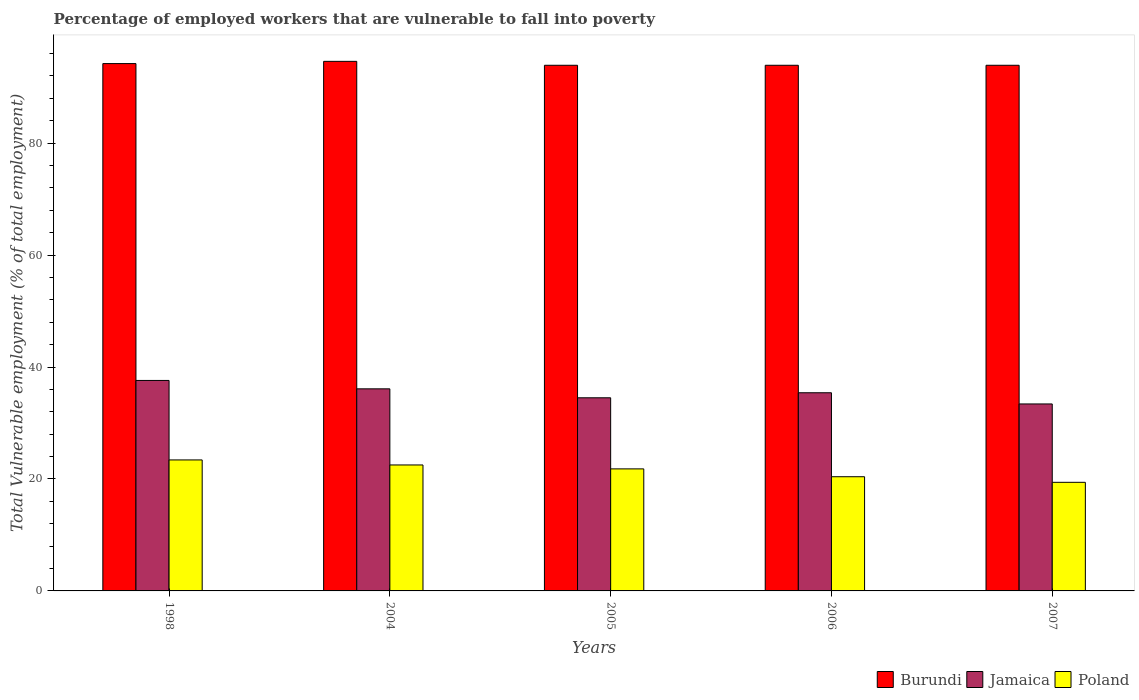How many groups of bars are there?
Provide a short and direct response. 5. Are the number of bars per tick equal to the number of legend labels?
Make the answer very short. Yes. Are the number of bars on each tick of the X-axis equal?
Your response must be concise. Yes. How many bars are there on the 2nd tick from the right?
Provide a short and direct response. 3. What is the percentage of employed workers who are vulnerable to fall into poverty in Poland in 2005?
Keep it short and to the point. 21.8. Across all years, what is the maximum percentage of employed workers who are vulnerable to fall into poverty in Poland?
Provide a succinct answer. 23.4. Across all years, what is the minimum percentage of employed workers who are vulnerable to fall into poverty in Jamaica?
Make the answer very short. 33.4. In which year was the percentage of employed workers who are vulnerable to fall into poverty in Jamaica minimum?
Offer a terse response. 2007. What is the total percentage of employed workers who are vulnerable to fall into poverty in Jamaica in the graph?
Provide a short and direct response. 177. What is the difference between the percentage of employed workers who are vulnerable to fall into poverty in Jamaica in 2004 and that in 2006?
Your response must be concise. 0.7. What is the difference between the percentage of employed workers who are vulnerable to fall into poverty in Burundi in 2007 and the percentage of employed workers who are vulnerable to fall into poverty in Poland in 2005?
Ensure brevity in your answer.  72.1. What is the average percentage of employed workers who are vulnerable to fall into poverty in Jamaica per year?
Offer a very short reply. 35.4. In the year 2005, what is the difference between the percentage of employed workers who are vulnerable to fall into poverty in Burundi and percentage of employed workers who are vulnerable to fall into poverty in Poland?
Provide a succinct answer. 72.1. In how many years, is the percentage of employed workers who are vulnerable to fall into poverty in Jamaica greater than 80 %?
Keep it short and to the point. 0. What is the ratio of the percentage of employed workers who are vulnerable to fall into poverty in Poland in 1998 to that in 2006?
Give a very brief answer. 1.15. Is the percentage of employed workers who are vulnerable to fall into poverty in Poland in 1998 less than that in 2007?
Offer a terse response. No. What is the difference between the highest and the second highest percentage of employed workers who are vulnerable to fall into poverty in Burundi?
Give a very brief answer. 0.4. What is the difference between the highest and the lowest percentage of employed workers who are vulnerable to fall into poverty in Poland?
Your answer should be very brief. 4. What does the 2nd bar from the left in 1998 represents?
Your answer should be very brief. Jamaica. What does the 1st bar from the right in 1998 represents?
Provide a succinct answer. Poland. Is it the case that in every year, the sum of the percentage of employed workers who are vulnerable to fall into poverty in Burundi and percentage of employed workers who are vulnerable to fall into poverty in Jamaica is greater than the percentage of employed workers who are vulnerable to fall into poverty in Poland?
Provide a short and direct response. Yes. How many bars are there?
Your answer should be compact. 15. What is the difference between two consecutive major ticks on the Y-axis?
Offer a terse response. 20. Does the graph contain any zero values?
Your answer should be compact. No. Does the graph contain grids?
Your response must be concise. No. What is the title of the graph?
Your response must be concise. Percentage of employed workers that are vulnerable to fall into poverty. What is the label or title of the X-axis?
Offer a terse response. Years. What is the label or title of the Y-axis?
Ensure brevity in your answer.  Total Vulnerable employment (% of total employment). What is the Total Vulnerable employment (% of total employment) in Burundi in 1998?
Provide a short and direct response. 94.2. What is the Total Vulnerable employment (% of total employment) in Jamaica in 1998?
Provide a succinct answer. 37.6. What is the Total Vulnerable employment (% of total employment) of Poland in 1998?
Keep it short and to the point. 23.4. What is the Total Vulnerable employment (% of total employment) in Burundi in 2004?
Provide a succinct answer. 94.6. What is the Total Vulnerable employment (% of total employment) in Jamaica in 2004?
Your response must be concise. 36.1. What is the Total Vulnerable employment (% of total employment) of Burundi in 2005?
Provide a short and direct response. 93.9. What is the Total Vulnerable employment (% of total employment) of Jamaica in 2005?
Offer a terse response. 34.5. What is the Total Vulnerable employment (% of total employment) in Poland in 2005?
Your answer should be very brief. 21.8. What is the Total Vulnerable employment (% of total employment) of Burundi in 2006?
Your answer should be compact. 93.9. What is the Total Vulnerable employment (% of total employment) in Jamaica in 2006?
Your answer should be compact. 35.4. What is the Total Vulnerable employment (% of total employment) in Poland in 2006?
Offer a very short reply. 20.4. What is the Total Vulnerable employment (% of total employment) in Burundi in 2007?
Provide a short and direct response. 93.9. What is the Total Vulnerable employment (% of total employment) in Jamaica in 2007?
Your response must be concise. 33.4. What is the Total Vulnerable employment (% of total employment) in Poland in 2007?
Provide a short and direct response. 19.4. Across all years, what is the maximum Total Vulnerable employment (% of total employment) of Burundi?
Your answer should be compact. 94.6. Across all years, what is the maximum Total Vulnerable employment (% of total employment) in Jamaica?
Make the answer very short. 37.6. Across all years, what is the maximum Total Vulnerable employment (% of total employment) of Poland?
Give a very brief answer. 23.4. Across all years, what is the minimum Total Vulnerable employment (% of total employment) of Burundi?
Provide a succinct answer. 93.9. Across all years, what is the minimum Total Vulnerable employment (% of total employment) of Jamaica?
Your answer should be compact. 33.4. Across all years, what is the minimum Total Vulnerable employment (% of total employment) of Poland?
Provide a short and direct response. 19.4. What is the total Total Vulnerable employment (% of total employment) of Burundi in the graph?
Keep it short and to the point. 470.5. What is the total Total Vulnerable employment (% of total employment) of Jamaica in the graph?
Provide a short and direct response. 177. What is the total Total Vulnerable employment (% of total employment) of Poland in the graph?
Provide a short and direct response. 107.5. What is the difference between the Total Vulnerable employment (% of total employment) of Burundi in 1998 and that in 2004?
Your answer should be compact. -0.4. What is the difference between the Total Vulnerable employment (% of total employment) in Poland in 1998 and that in 2004?
Provide a short and direct response. 0.9. What is the difference between the Total Vulnerable employment (% of total employment) in Poland in 1998 and that in 2005?
Make the answer very short. 1.6. What is the difference between the Total Vulnerable employment (% of total employment) of Poland in 1998 and that in 2006?
Offer a terse response. 3. What is the difference between the Total Vulnerable employment (% of total employment) in Poland in 2004 and that in 2005?
Offer a terse response. 0.7. What is the difference between the Total Vulnerable employment (% of total employment) of Burundi in 2004 and that in 2006?
Provide a succinct answer. 0.7. What is the difference between the Total Vulnerable employment (% of total employment) in Jamaica in 2004 and that in 2006?
Offer a very short reply. 0.7. What is the difference between the Total Vulnerable employment (% of total employment) in Burundi in 2004 and that in 2007?
Make the answer very short. 0.7. What is the difference between the Total Vulnerable employment (% of total employment) in Poland in 2004 and that in 2007?
Offer a terse response. 3.1. What is the difference between the Total Vulnerable employment (% of total employment) of Burundi in 2005 and that in 2006?
Provide a short and direct response. 0. What is the difference between the Total Vulnerable employment (% of total employment) in Jamaica in 2005 and that in 2006?
Provide a succinct answer. -0.9. What is the difference between the Total Vulnerable employment (% of total employment) in Jamaica in 2005 and that in 2007?
Your answer should be compact. 1.1. What is the difference between the Total Vulnerable employment (% of total employment) in Burundi in 2006 and that in 2007?
Provide a short and direct response. 0. What is the difference between the Total Vulnerable employment (% of total employment) of Jamaica in 2006 and that in 2007?
Keep it short and to the point. 2. What is the difference between the Total Vulnerable employment (% of total employment) of Poland in 2006 and that in 2007?
Provide a short and direct response. 1. What is the difference between the Total Vulnerable employment (% of total employment) of Burundi in 1998 and the Total Vulnerable employment (% of total employment) of Jamaica in 2004?
Your response must be concise. 58.1. What is the difference between the Total Vulnerable employment (% of total employment) of Burundi in 1998 and the Total Vulnerable employment (% of total employment) of Poland in 2004?
Your answer should be very brief. 71.7. What is the difference between the Total Vulnerable employment (% of total employment) in Jamaica in 1998 and the Total Vulnerable employment (% of total employment) in Poland in 2004?
Offer a very short reply. 15.1. What is the difference between the Total Vulnerable employment (% of total employment) in Burundi in 1998 and the Total Vulnerable employment (% of total employment) in Jamaica in 2005?
Your answer should be compact. 59.7. What is the difference between the Total Vulnerable employment (% of total employment) in Burundi in 1998 and the Total Vulnerable employment (% of total employment) in Poland in 2005?
Your response must be concise. 72.4. What is the difference between the Total Vulnerable employment (% of total employment) of Burundi in 1998 and the Total Vulnerable employment (% of total employment) of Jamaica in 2006?
Ensure brevity in your answer.  58.8. What is the difference between the Total Vulnerable employment (% of total employment) of Burundi in 1998 and the Total Vulnerable employment (% of total employment) of Poland in 2006?
Provide a succinct answer. 73.8. What is the difference between the Total Vulnerable employment (% of total employment) in Burundi in 1998 and the Total Vulnerable employment (% of total employment) in Jamaica in 2007?
Your response must be concise. 60.8. What is the difference between the Total Vulnerable employment (% of total employment) in Burundi in 1998 and the Total Vulnerable employment (% of total employment) in Poland in 2007?
Make the answer very short. 74.8. What is the difference between the Total Vulnerable employment (% of total employment) in Burundi in 2004 and the Total Vulnerable employment (% of total employment) in Jamaica in 2005?
Keep it short and to the point. 60.1. What is the difference between the Total Vulnerable employment (% of total employment) in Burundi in 2004 and the Total Vulnerable employment (% of total employment) in Poland in 2005?
Your answer should be compact. 72.8. What is the difference between the Total Vulnerable employment (% of total employment) of Burundi in 2004 and the Total Vulnerable employment (% of total employment) of Jamaica in 2006?
Ensure brevity in your answer.  59.2. What is the difference between the Total Vulnerable employment (% of total employment) in Burundi in 2004 and the Total Vulnerable employment (% of total employment) in Poland in 2006?
Make the answer very short. 74.2. What is the difference between the Total Vulnerable employment (% of total employment) in Burundi in 2004 and the Total Vulnerable employment (% of total employment) in Jamaica in 2007?
Give a very brief answer. 61.2. What is the difference between the Total Vulnerable employment (% of total employment) of Burundi in 2004 and the Total Vulnerable employment (% of total employment) of Poland in 2007?
Make the answer very short. 75.2. What is the difference between the Total Vulnerable employment (% of total employment) of Jamaica in 2004 and the Total Vulnerable employment (% of total employment) of Poland in 2007?
Make the answer very short. 16.7. What is the difference between the Total Vulnerable employment (% of total employment) of Burundi in 2005 and the Total Vulnerable employment (% of total employment) of Jamaica in 2006?
Your answer should be very brief. 58.5. What is the difference between the Total Vulnerable employment (% of total employment) of Burundi in 2005 and the Total Vulnerable employment (% of total employment) of Poland in 2006?
Make the answer very short. 73.5. What is the difference between the Total Vulnerable employment (% of total employment) in Burundi in 2005 and the Total Vulnerable employment (% of total employment) in Jamaica in 2007?
Provide a succinct answer. 60.5. What is the difference between the Total Vulnerable employment (% of total employment) of Burundi in 2005 and the Total Vulnerable employment (% of total employment) of Poland in 2007?
Offer a terse response. 74.5. What is the difference between the Total Vulnerable employment (% of total employment) in Jamaica in 2005 and the Total Vulnerable employment (% of total employment) in Poland in 2007?
Your response must be concise. 15.1. What is the difference between the Total Vulnerable employment (% of total employment) of Burundi in 2006 and the Total Vulnerable employment (% of total employment) of Jamaica in 2007?
Provide a succinct answer. 60.5. What is the difference between the Total Vulnerable employment (% of total employment) in Burundi in 2006 and the Total Vulnerable employment (% of total employment) in Poland in 2007?
Your answer should be very brief. 74.5. What is the difference between the Total Vulnerable employment (% of total employment) in Jamaica in 2006 and the Total Vulnerable employment (% of total employment) in Poland in 2007?
Your answer should be compact. 16. What is the average Total Vulnerable employment (% of total employment) in Burundi per year?
Your answer should be very brief. 94.1. What is the average Total Vulnerable employment (% of total employment) in Jamaica per year?
Your response must be concise. 35.4. In the year 1998, what is the difference between the Total Vulnerable employment (% of total employment) of Burundi and Total Vulnerable employment (% of total employment) of Jamaica?
Make the answer very short. 56.6. In the year 1998, what is the difference between the Total Vulnerable employment (% of total employment) in Burundi and Total Vulnerable employment (% of total employment) in Poland?
Give a very brief answer. 70.8. In the year 2004, what is the difference between the Total Vulnerable employment (% of total employment) in Burundi and Total Vulnerable employment (% of total employment) in Jamaica?
Provide a short and direct response. 58.5. In the year 2004, what is the difference between the Total Vulnerable employment (% of total employment) of Burundi and Total Vulnerable employment (% of total employment) of Poland?
Offer a terse response. 72.1. In the year 2004, what is the difference between the Total Vulnerable employment (% of total employment) of Jamaica and Total Vulnerable employment (% of total employment) of Poland?
Your answer should be very brief. 13.6. In the year 2005, what is the difference between the Total Vulnerable employment (% of total employment) in Burundi and Total Vulnerable employment (% of total employment) in Jamaica?
Offer a very short reply. 59.4. In the year 2005, what is the difference between the Total Vulnerable employment (% of total employment) in Burundi and Total Vulnerable employment (% of total employment) in Poland?
Your answer should be very brief. 72.1. In the year 2006, what is the difference between the Total Vulnerable employment (% of total employment) of Burundi and Total Vulnerable employment (% of total employment) of Jamaica?
Offer a very short reply. 58.5. In the year 2006, what is the difference between the Total Vulnerable employment (% of total employment) of Burundi and Total Vulnerable employment (% of total employment) of Poland?
Your answer should be compact. 73.5. In the year 2007, what is the difference between the Total Vulnerable employment (% of total employment) in Burundi and Total Vulnerable employment (% of total employment) in Jamaica?
Provide a short and direct response. 60.5. In the year 2007, what is the difference between the Total Vulnerable employment (% of total employment) of Burundi and Total Vulnerable employment (% of total employment) of Poland?
Your answer should be compact. 74.5. What is the ratio of the Total Vulnerable employment (% of total employment) of Burundi in 1998 to that in 2004?
Provide a short and direct response. 1. What is the ratio of the Total Vulnerable employment (% of total employment) of Jamaica in 1998 to that in 2004?
Your answer should be compact. 1.04. What is the ratio of the Total Vulnerable employment (% of total employment) in Poland in 1998 to that in 2004?
Offer a very short reply. 1.04. What is the ratio of the Total Vulnerable employment (% of total employment) of Burundi in 1998 to that in 2005?
Offer a terse response. 1. What is the ratio of the Total Vulnerable employment (% of total employment) of Jamaica in 1998 to that in 2005?
Keep it short and to the point. 1.09. What is the ratio of the Total Vulnerable employment (% of total employment) of Poland in 1998 to that in 2005?
Give a very brief answer. 1.07. What is the ratio of the Total Vulnerable employment (% of total employment) of Jamaica in 1998 to that in 2006?
Offer a very short reply. 1.06. What is the ratio of the Total Vulnerable employment (% of total employment) in Poland in 1998 to that in 2006?
Your response must be concise. 1.15. What is the ratio of the Total Vulnerable employment (% of total employment) of Jamaica in 1998 to that in 2007?
Provide a succinct answer. 1.13. What is the ratio of the Total Vulnerable employment (% of total employment) of Poland in 1998 to that in 2007?
Your answer should be very brief. 1.21. What is the ratio of the Total Vulnerable employment (% of total employment) of Burundi in 2004 to that in 2005?
Your answer should be compact. 1.01. What is the ratio of the Total Vulnerable employment (% of total employment) of Jamaica in 2004 to that in 2005?
Make the answer very short. 1.05. What is the ratio of the Total Vulnerable employment (% of total employment) in Poland in 2004 to that in 2005?
Offer a terse response. 1.03. What is the ratio of the Total Vulnerable employment (% of total employment) of Burundi in 2004 to that in 2006?
Keep it short and to the point. 1.01. What is the ratio of the Total Vulnerable employment (% of total employment) in Jamaica in 2004 to that in 2006?
Offer a terse response. 1.02. What is the ratio of the Total Vulnerable employment (% of total employment) of Poland in 2004 to that in 2006?
Offer a terse response. 1.1. What is the ratio of the Total Vulnerable employment (% of total employment) of Burundi in 2004 to that in 2007?
Provide a succinct answer. 1.01. What is the ratio of the Total Vulnerable employment (% of total employment) of Jamaica in 2004 to that in 2007?
Offer a terse response. 1.08. What is the ratio of the Total Vulnerable employment (% of total employment) of Poland in 2004 to that in 2007?
Your answer should be very brief. 1.16. What is the ratio of the Total Vulnerable employment (% of total employment) in Jamaica in 2005 to that in 2006?
Your answer should be compact. 0.97. What is the ratio of the Total Vulnerable employment (% of total employment) of Poland in 2005 to that in 2006?
Ensure brevity in your answer.  1.07. What is the ratio of the Total Vulnerable employment (% of total employment) of Burundi in 2005 to that in 2007?
Provide a succinct answer. 1. What is the ratio of the Total Vulnerable employment (% of total employment) in Jamaica in 2005 to that in 2007?
Your answer should be compact. 1.03. What is the ratio of the Total Vulnerable employment (% of total employment) of Poland in 2005 to that in 2007?
Give a very brief answer. 1.12. What is the ratio of the Total Vulnerable employment (% of total employment) of Burundi in 2006 to that in 2007?
Your answer should be very brief. 1. What is the ratio of the Total Vulnerable employment (% of total employment) in Jamaica in 2006 to that in 2007?
Your answer should be compact. 1.06. What is the ratio of the Total Vulnerable employment (% of total employment) of Poland in 2006 to that in 2007?
Make the answer very short. 1.05. What is the difference between the highest and the second highest Total Vulnerable employment (% of total employment) in Burundi?
Offer a very short reply. 0.4. What is the difference between the highest and the lowest Total Vulnerable employment (% of total employment) of Burundi?
Ensure brevity in your answer.  0.7. What is the difference between the highest and the lowest Total Vulnerable employment (% of total employment) of Poland?
Give a very brief answer. 4. 